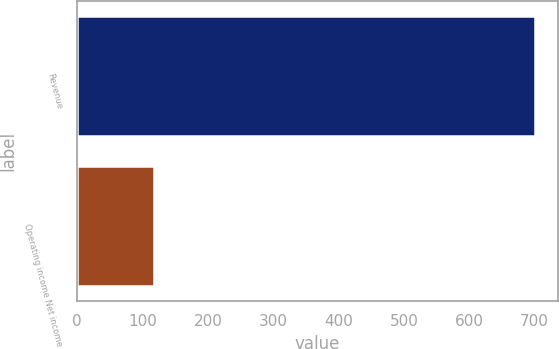Convert chart. <chart><loc_0><loc_0><loc_500><loc_500><bar_chart><fcel>Revenue<fcel>Operating income Net income<nl><fcel>700.5<fcel>117.7<nl></chart> 